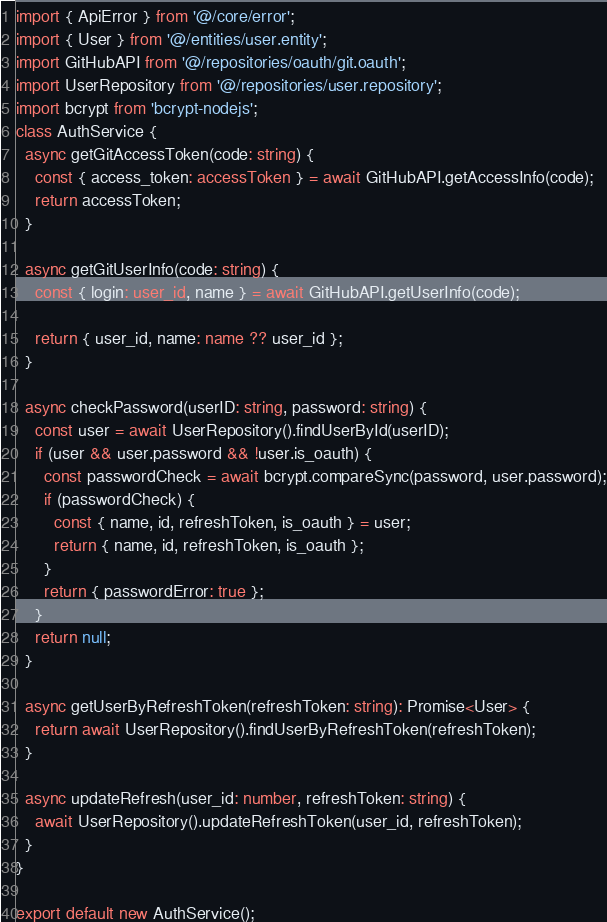<code> <loc_0><loc_0><loc_500><loc_500><_TypeScript_>import { ApiError } from '@/core/error';
import { User } from '@/entities/user.entity';
import GitHubAPI from '@/repositories/oauth/git.oauth';
import UserRepository from '@/repositories/user.repository';
import bcrypt from 'bcrypt-nodejs';
class AuthService {
  async getGitAccessToken(code: string) {
    const { access_token: accessToken } = await GitHubAPI.getAccessInfo(code);
    return accessToken;
  }

  async getGitUserInfo(code: string) {
    const { login: user_id, name } = await GitHubAPI.getUserInfo(code);

    return { user_id, name: name ?? user_id };
  }

  async checkPassword(userID: string, password: string) {
    const user = await UserRepository().findUserById(userID);
    if (user && user.password && !user.is_oauth) {
      const passwordCheck = await bcrypt.compareSync(password, user.password);
      if (passwordCheck) {
        const { name, id, refreshToken, is_oauth } = user;
        return { name, id, refreshToken, is_oauth };
      }
      return { passwordError: true };
    }
    return null;
  }

  async getUserByRefreshToken(refreshToken: string): Promise<User> {
    return await UserRepository().findUserByRefreshToken(refreshToken);
  }

  async updateRefresh(user_id: number, refreshToken: string) {
    await UserRepository().updateRefreshToken(user_id, refreshToken);
  }
}

export default new AuthService();
</code> 